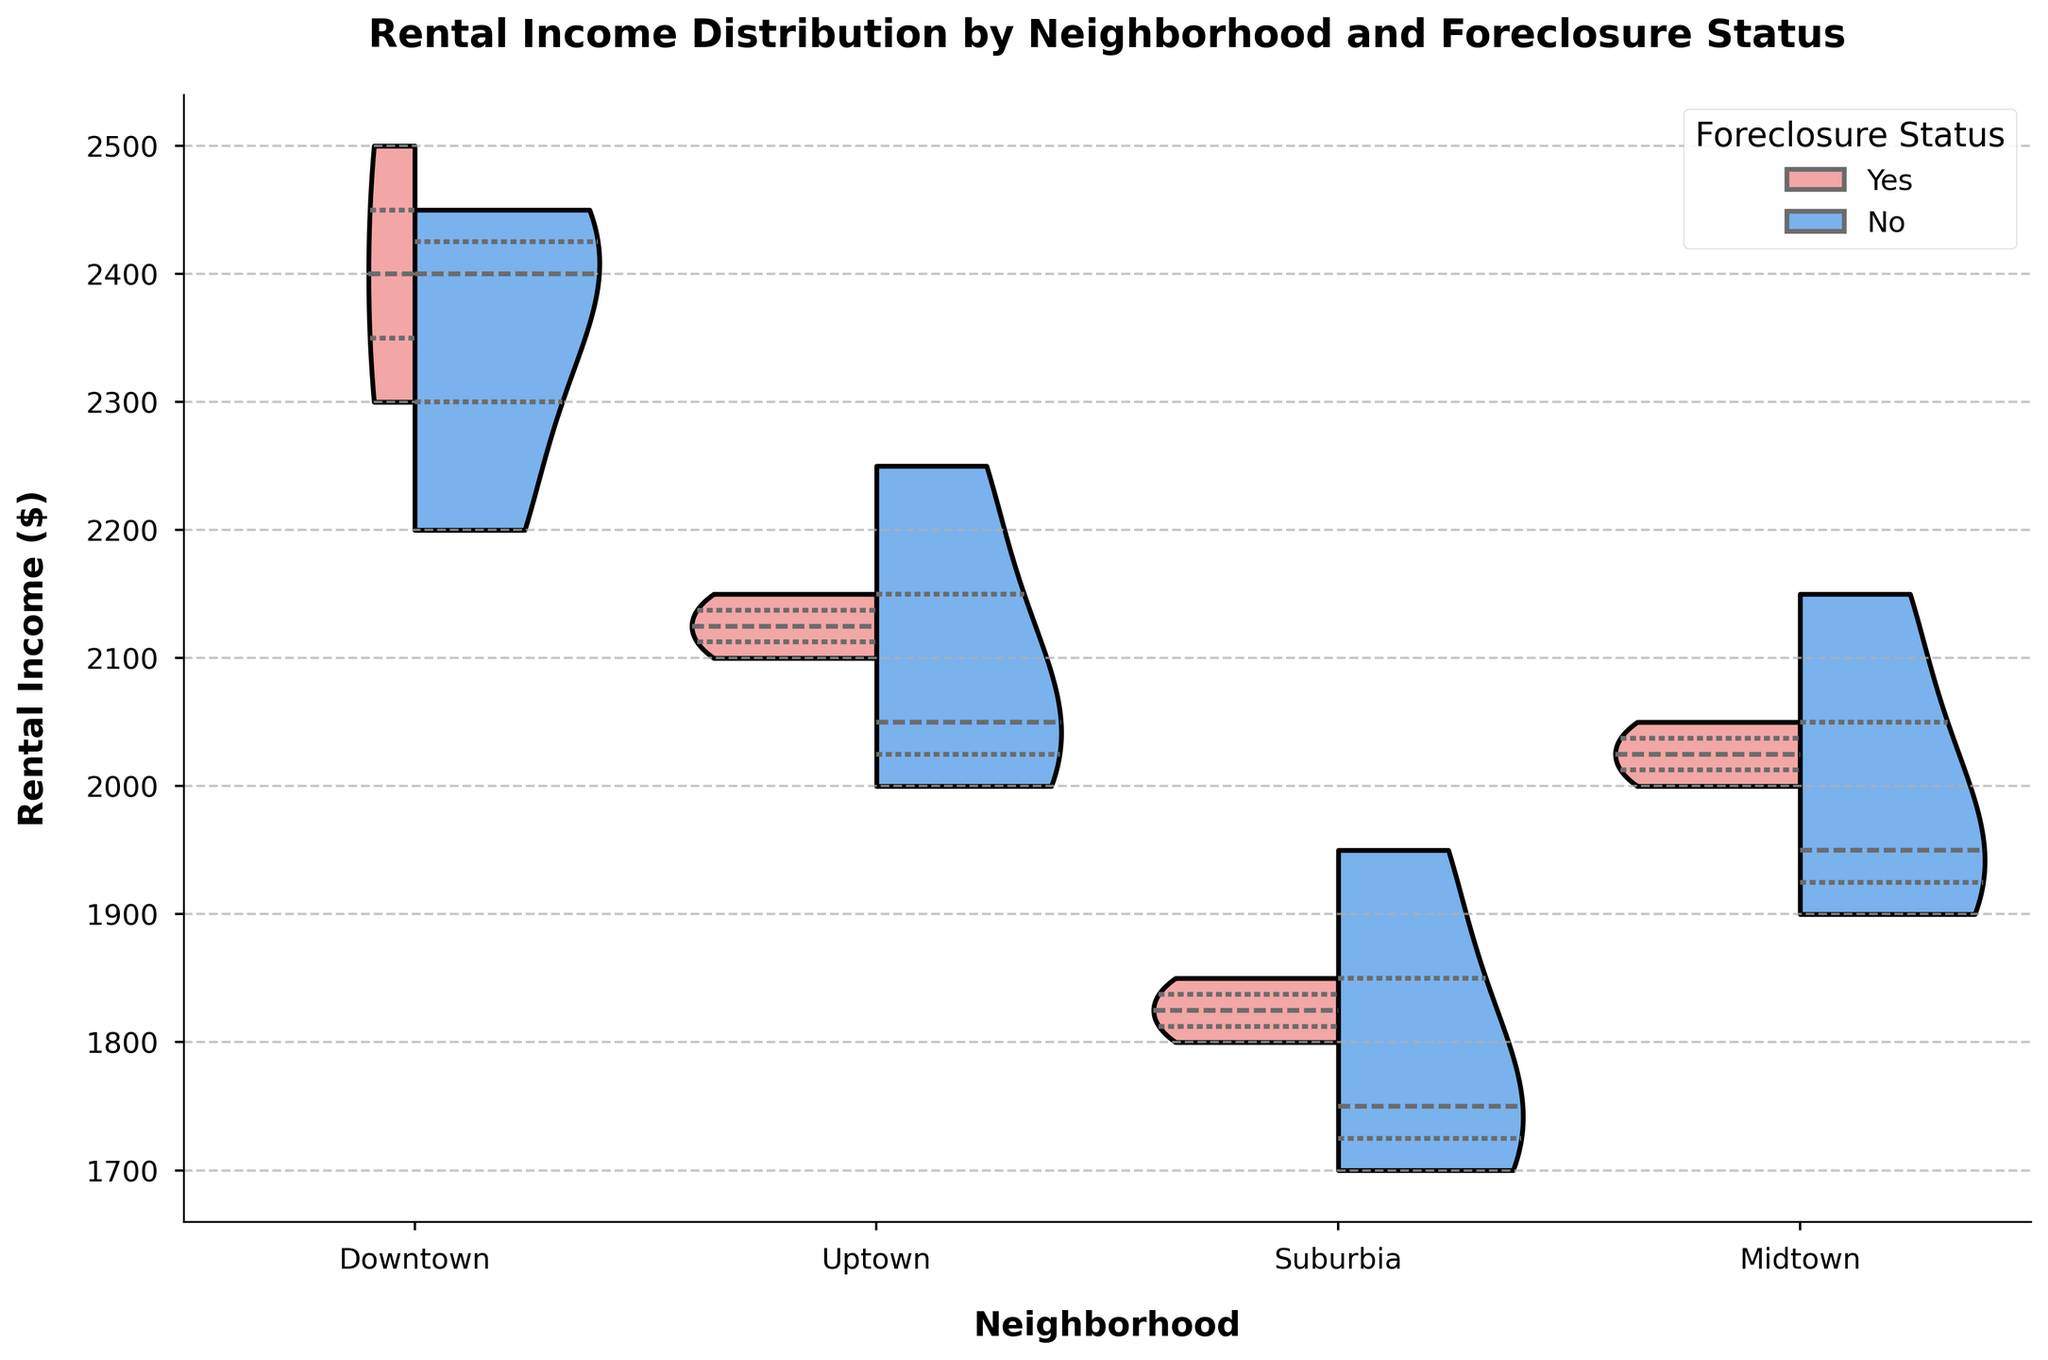What is the title of the figure? The title is given at the top of the figure in bold.
Answer: Rental Income Distribution by Neighborhood and Foreclosure Status Which neighborhood shows the highest maximum rental income? The highest maximum rental income is represented by the top end of the violin plot on the y-axis.
Answer: Downtown In Uptown, do foreclosed homes generally have higher or lower rental income compared to non-foreclosed homes? Compare the height of the violins within Uptown; the portion for 'Yes' (foreclosed) vs. 'No' (non-foreclosed).
Answer: Lower What is the range of rental income for non-foreclosed homes in Suburbia? Look at the range of the blue portion of the violin plot in Suburbia; it spans vertically from the minimum to the maximum value.
Answer: 1700 to 1950 Which neighborhood has the most balanced rental income distribution between foreclosed and non-foreclosed homes? Check the overlap and similarity in the shapes and sizes of the foreclosed (red) and non-foreclosed (blue) portions of the violin plots across neighborhoods.
Answer: Midtown What is the median rental income for foreclosed homes in Downtown? The white dot within the red portion of the Downtown violin plot marks the median value.
Answer: 2400 Between Downtown and Uptown, which neighborhood has a wider range of rental incomes for non-foreclosed homes? Compare the spread (vertical range) of the blue portions of the violin plots for non-foreclosed homes in Downtown and Uptown.
Answer: Downtown What is the interquartile range (IQR) of rental income for foreclosed homes in Suburbia? Identify the 25th and 75th percentiles (edges of the thickest part) within the red portion of Suburbia, and calculate the difference.
Answer: 1800 to 1850 How does the median rental income for non-foreclosed homes in Midtown compare with that in Uptown? Compare the position of the white dots within the blue portions of the violin plots for non-foreclosed homes in Midtown and Uptown.
Answer: Higher in Midtown What conclusion can you draw about the rental income trends in foreclosed homes across all neighborhoods? Evaluate the positions and shapes of the red portions in all neighborhoods for a comprehensive comparison.
Answer: Foreclosed homes generally have lower or more varied rental incomes 